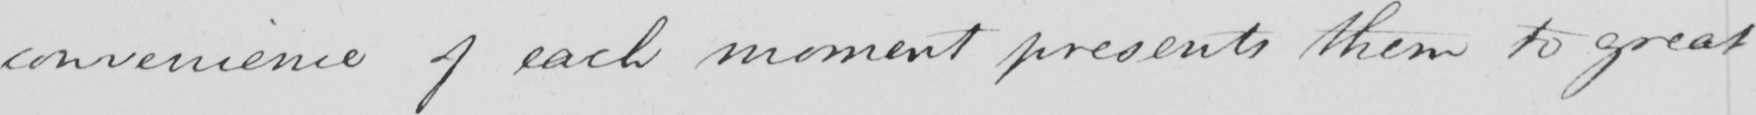Please provide the text content of this handwritten line. convenience of each moment presents them to great 